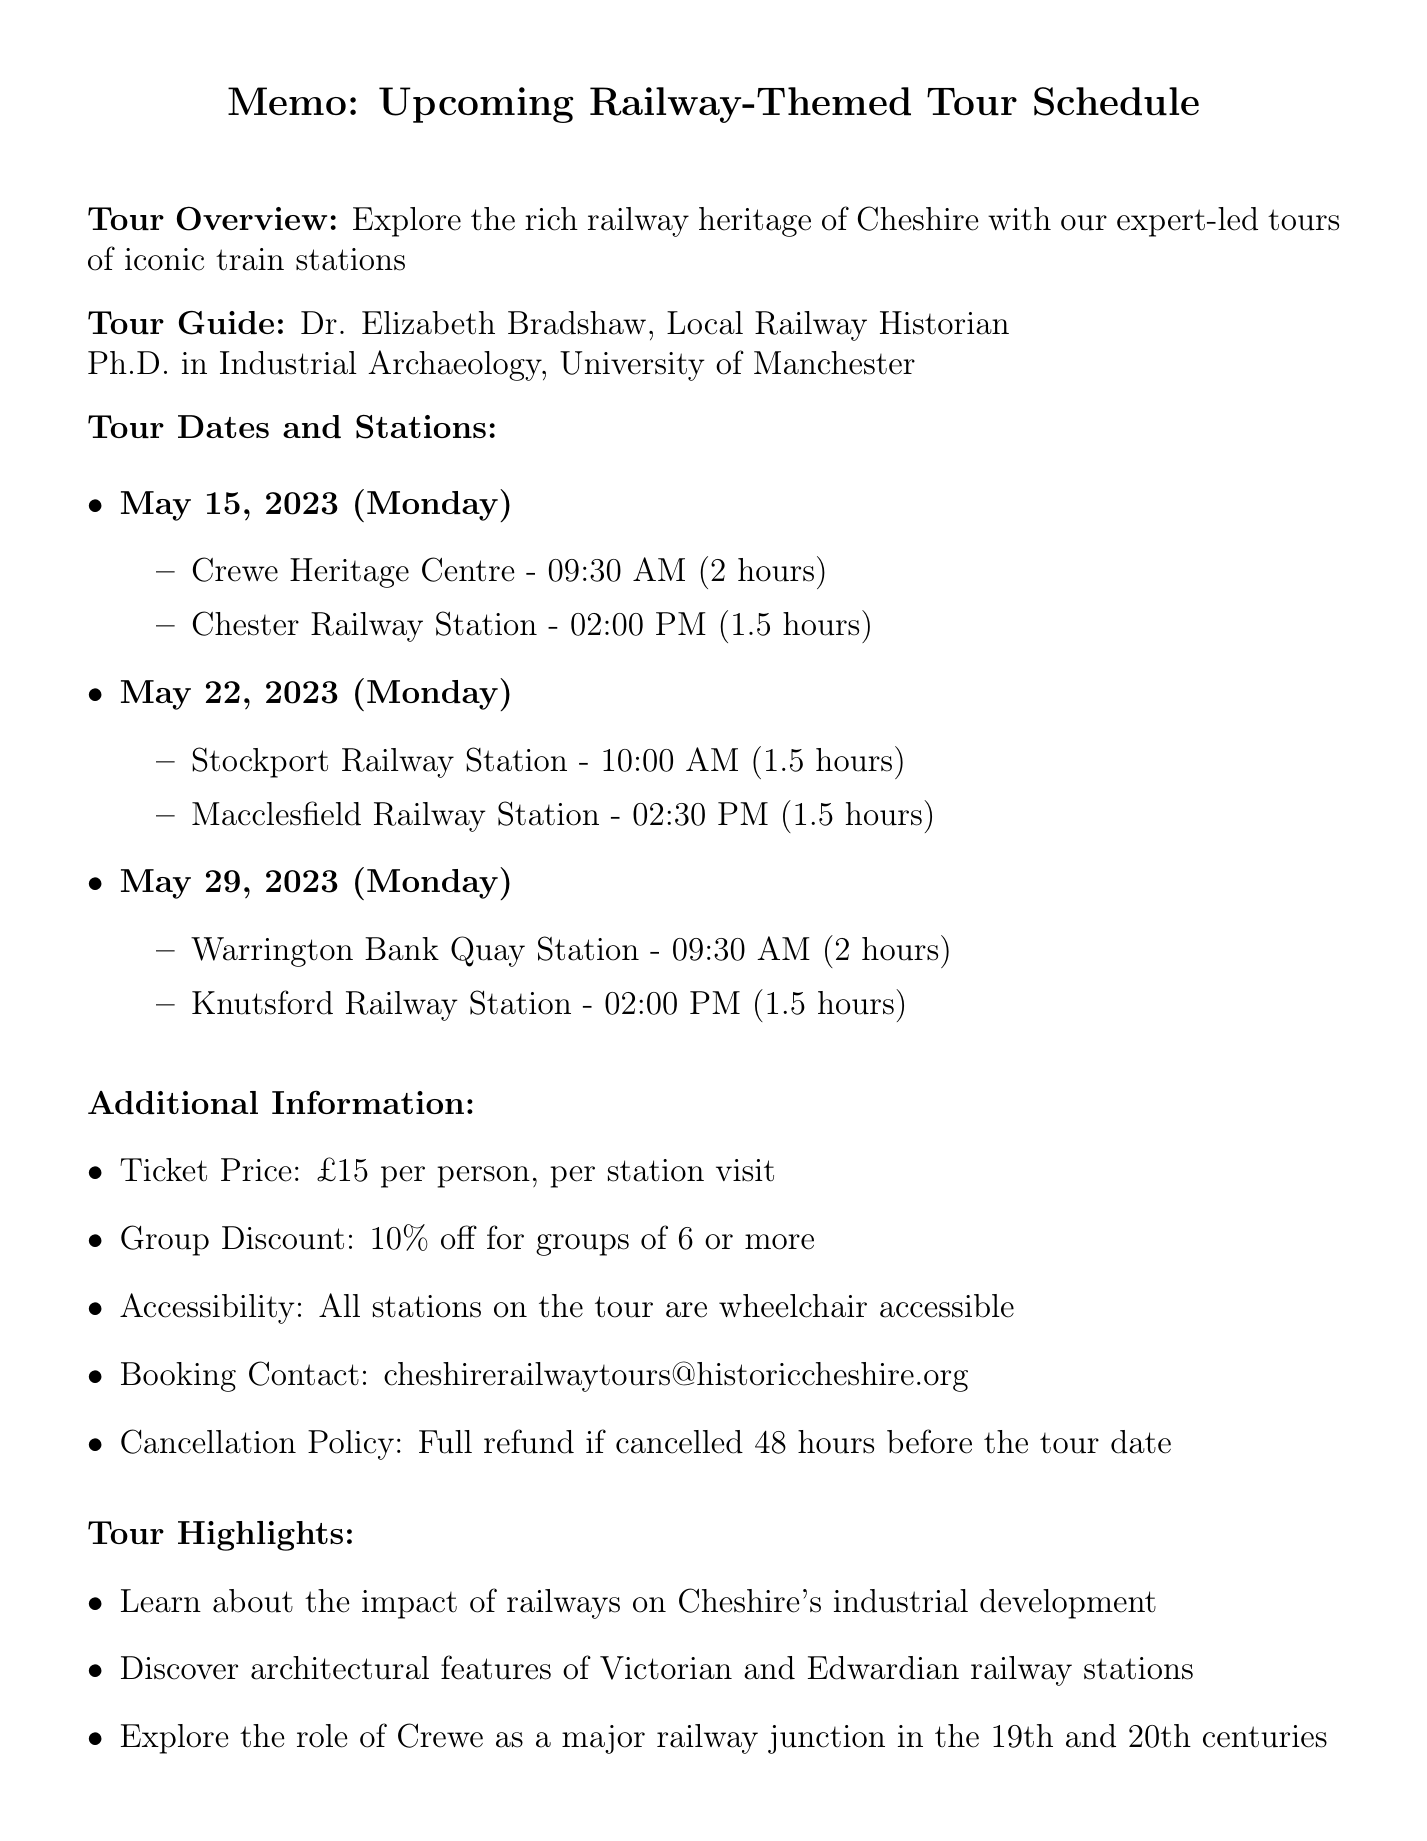What is the name of the tour? The name of the tour is highlighted in the document as "Historic Railway Journey of Cheshire."
Answer: Historic Railway Journey of Cheshire Who is the tour guide? The memo specifically identifies the tour guide as "Dr. Elizabeth Bradshaw."
Answer: Dr. Elizabeth Bradshaw What is the ticket price per person for each station visit? The document mentions the ticket price as "£15 per person, per station visit."
Answer: £15 per person, per station visit On what date will the tour visit Chester Railway Station? The document states that Chester Railway Station is visited on "May 15, 2023."
Answer: May 15, 2023 How long is the visit to Warrington Bank Quay Station? The document specifies the duration of the visit at Warrington Bank Quay Station as "2 hours."
Answer: 2 hours What discount is offered for groups? The additional information section states there is a "10% off for groups of 6 or more."
Answer: 10% off for groups of 6 or more When should participants cancel for a full refund? The cancellation policy mentions a full refund if cancelled "48 hours before the tour date."
Answer: 48 hours before the tour date What is one of the highlights of the tour? The document lists various highlights; one example is "Learn about the impact of railways on Cheshire's industrial development."
Answer: Learn about the impact of railways on Cheshire's industrial development Where will participants meet for the Macclesfield Railway Station visit? The document specifies the meeting point as "Platform 1 at Macclesfield Station."
Answer: Platform 1 at Macclesfield Station 